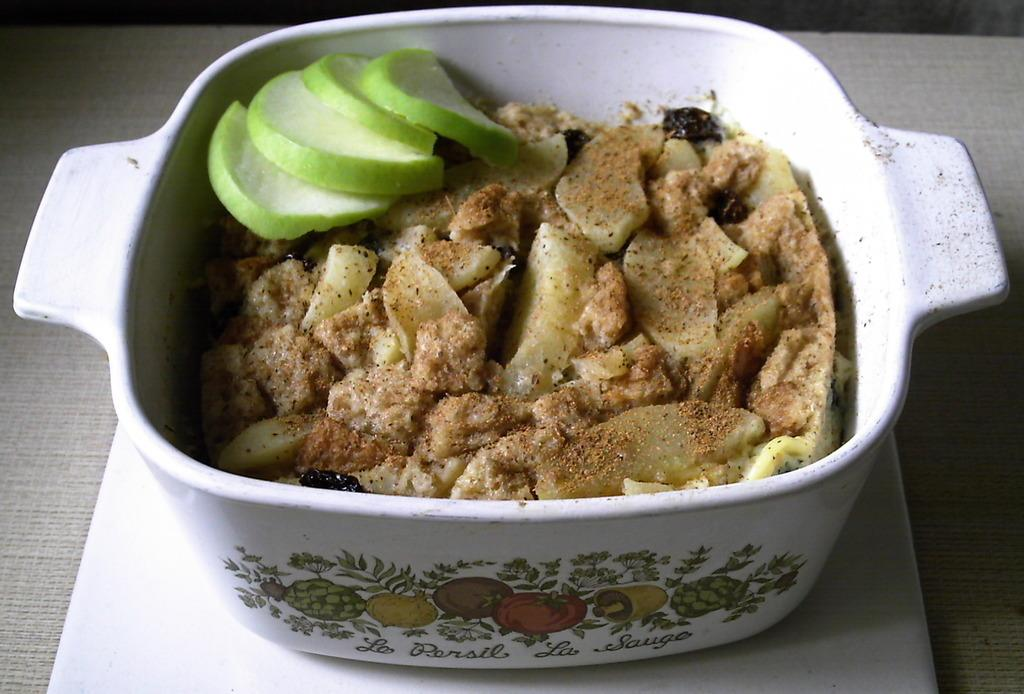What is the main object in the image? There is a vessel in the image. What is inside the vessel? Food items are present in the vessel. How are the food items arranged in the image? The food items are kept in a tray. Where is the tray located? The tray is on a table. Can you describe the setting of the image? The image is likely taken in a room. What type of bird can be seen pulling the vessel in the image? There is no bird present in the image, and the vessel is not being pulled. 